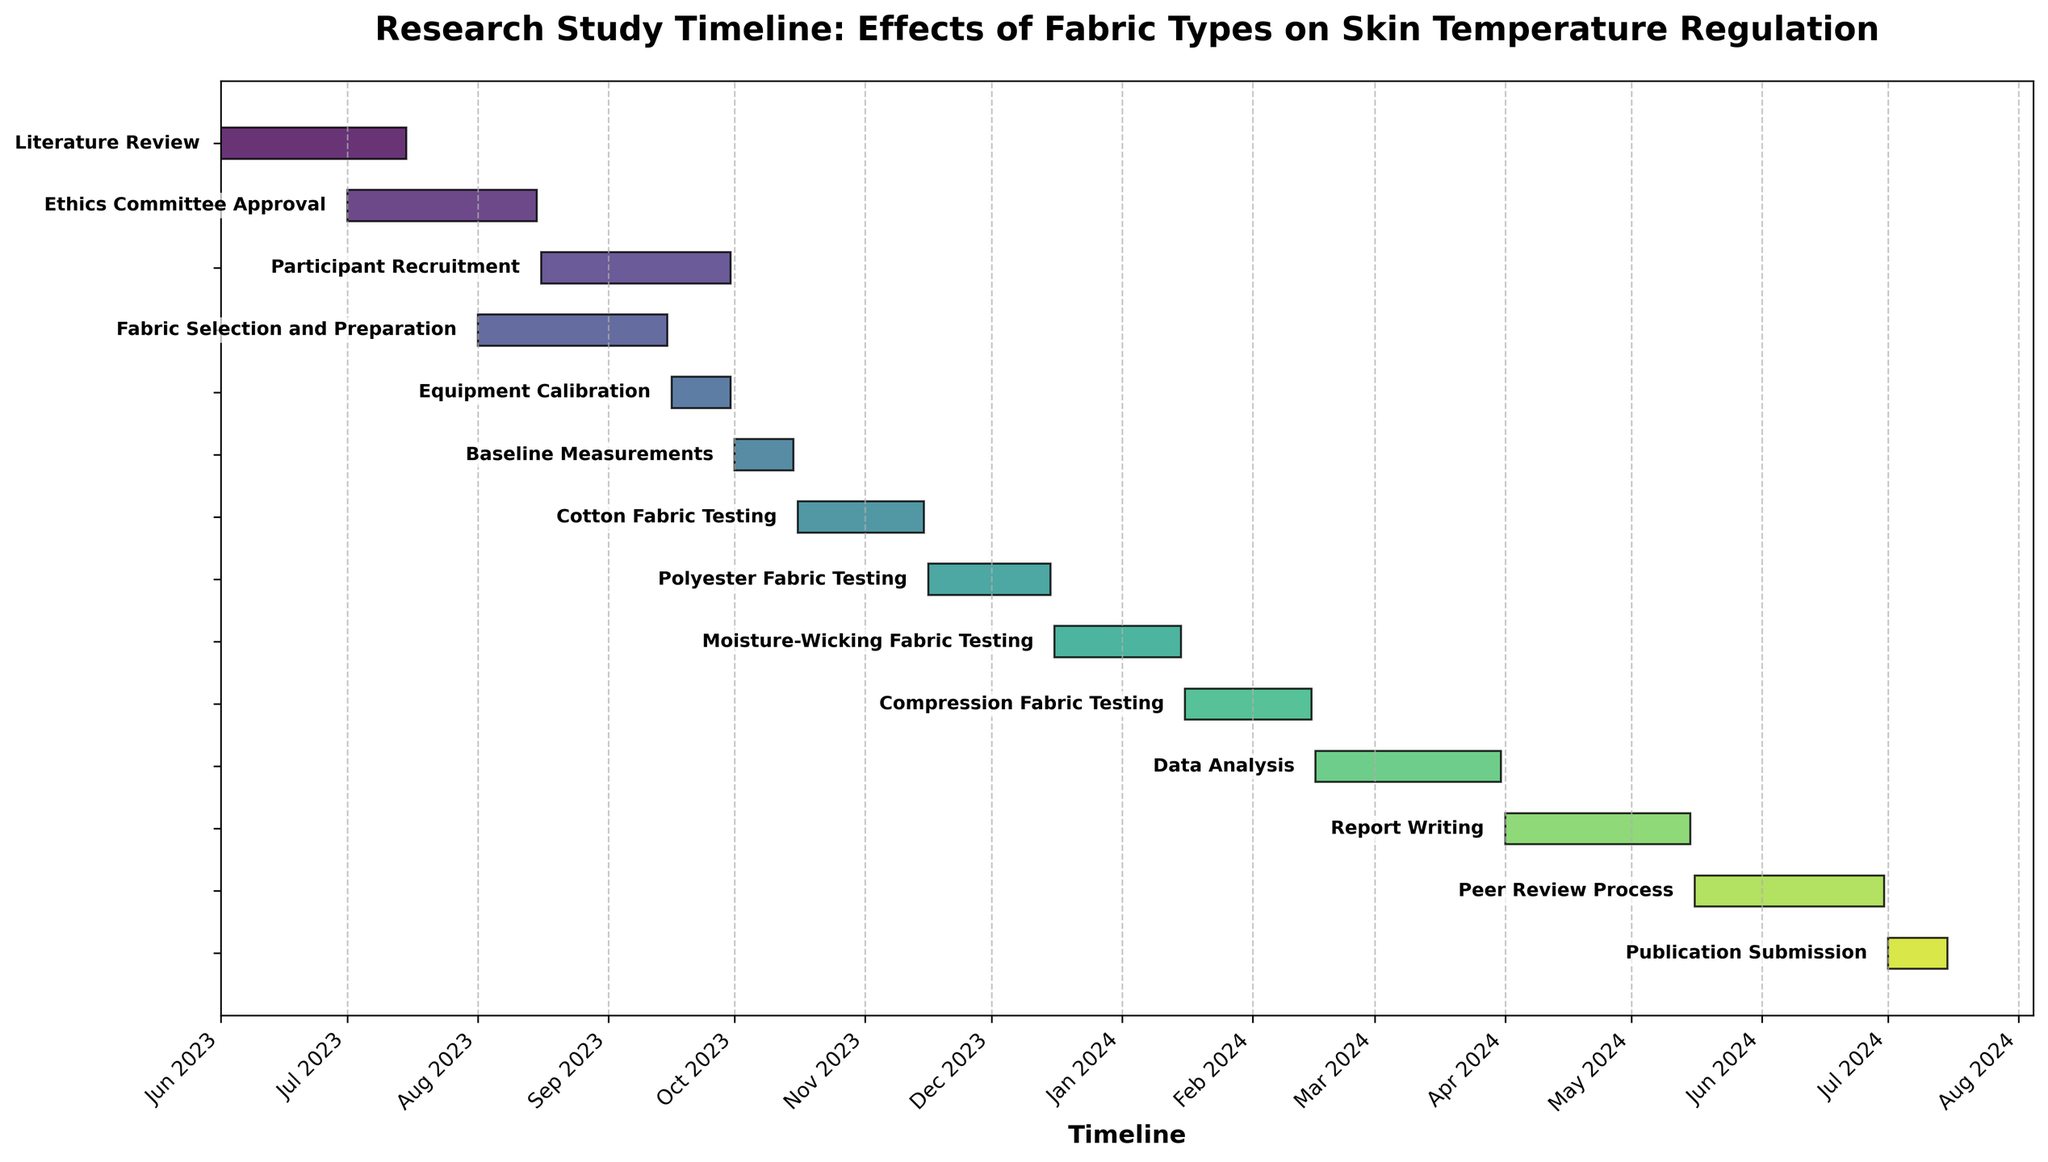What is the total duration of the 'Literature Review' task? From the figure, the 'Literature Review' task begins on June 1, 2023, and ends on July 15, 2023. The total duration can be calculated by finding the difference between these dates.
Answer: 45 days When does the 'Cotton Fabric Testing' start and end? The figure shows that 'Cotton Fabric Testing' starts on October 16, 2023, and ends on November 15, 2023.
Answer: Starts: October 16, 2023, Ends: November 15, 2023 Which task has the shortest duration? By comparing the lengths of all the bars representing each task, 'Publication Submission' has the shortest duration as its bar is the shortest in length.
Answer: Publication Submission Are there any tasks that overlap in their timelines? By examining the horizontal positions of the bars, 'Participant Recruitment' and 'Fabric Selection and Preparation' overlap as both span periods from August 16, 2023, to September 15, 2023.
Answer: Yes, 'Participant Recruitment' and 'Fabric Selection and Preparation' Is the 'Equipment Calibration' task completed before 'Baseline Measurements' start? The 'Equipment Calibration' task ends on September 30, 2023, while the 'Baseline Measurements' start on October 1, 2023. Since the end date of 'Equipment Calibration' is before the start date of 'Baseline Measurements', it is confirmed.
Answer: Yes What is the combined duration of 'Cotton Fabric Testing' and 'Polyester Fabric Testing'? The 'Cotton Fabric Testing' lasts from October 16, 2023, to November 15, 2023, and the 'Polyester Fabric Testing' lasts from November 16, 2023, to December 15, 2023. Each task spans 30 days, so their combined duration is 30 + 30.
Answer: 60 days How long is the gap between the end of 'Moisture-Wicking Fabric Testing' and the start of 'Compression Fabric Testing'? 'Moisture-Wicking Fabric Testing' ends on January 15, 2024, and 'Compression Fabric Testing' starts on January 16, 2024. The gap between these dates is only 1 day.
Answer: 1 day What is the final task in the research study timeline? The last task listed at the bottom of the figure is 'Publication Submission'.
Answer: Publication Submission Which task directly follows 'Baseline Measurements'? According to the sequence of tasks in the figure, 'Cotton Fabric Testing' directly follows 'Baseline Measurements' as indicated by its consecutive bar.
Answer: Cotton Fabric Testing 